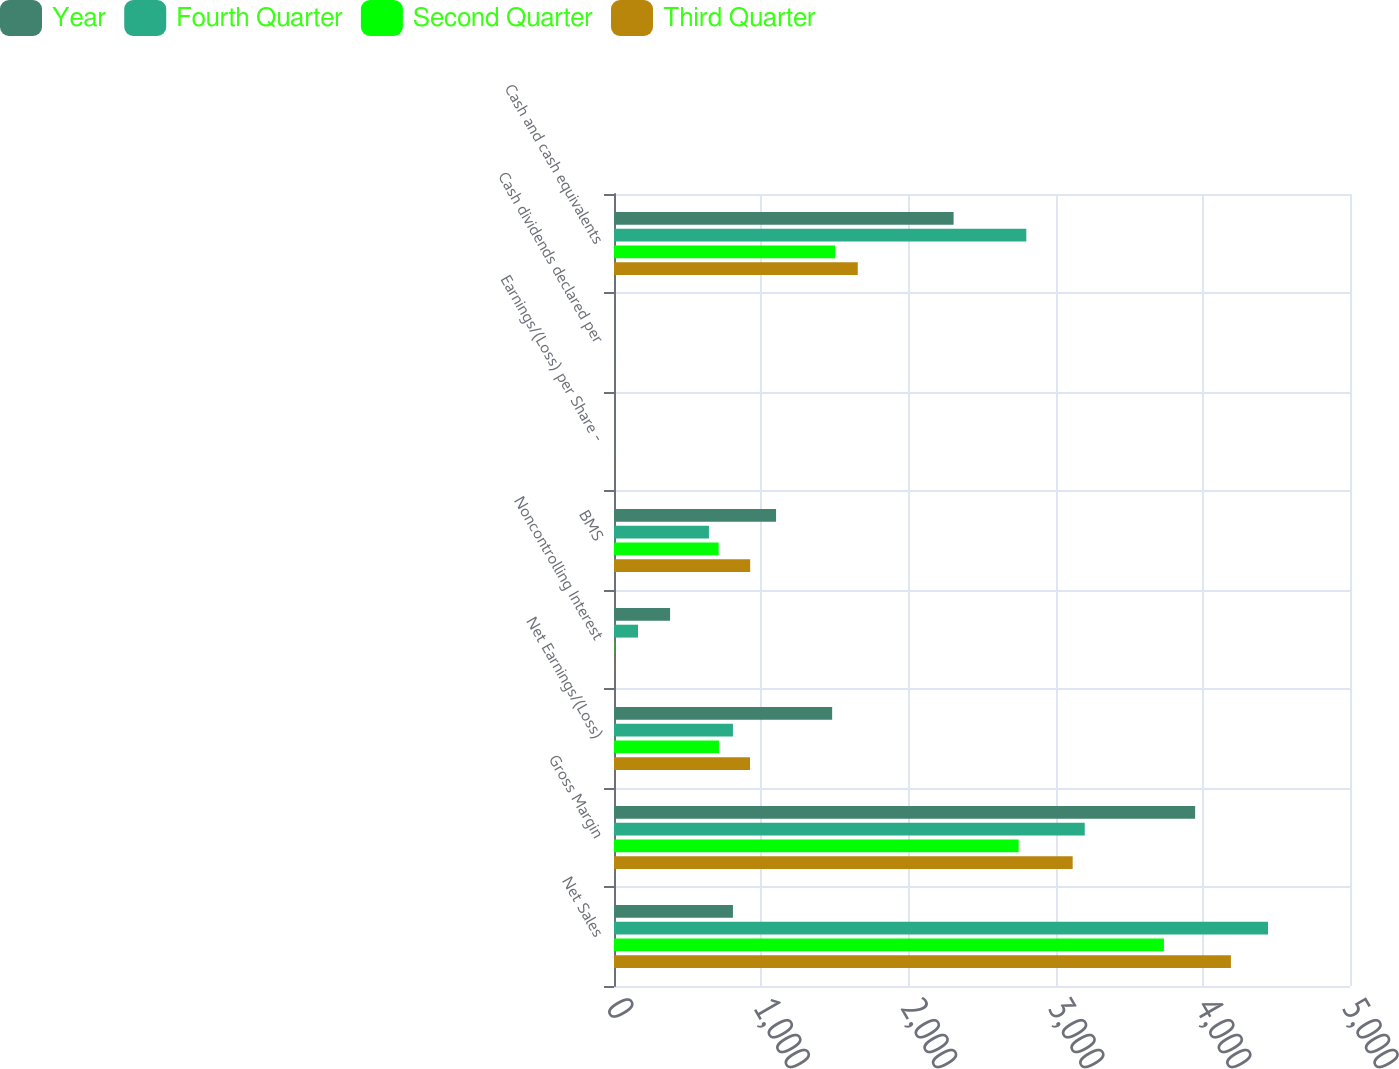<chart> <loc_0><loc_0><loc_500><loc_500><stacked_bar_chart><ecel><fcel>Net Sales<fcel>Gross Margin<fcel>Net Earnings/(Loss)<fcel>Noncontrolling Interest<fcel>BMS<fcel>Earnings/(Loss) per Share -<fcel>Cash dividends declared per<fcel>Cash and cash equivalents<nl><fcel>Year<fcel>808<fcel>3948<fcel>1482<fcel>381<fcel>1101<fcel>0.65<fcel>0.34<fcel>2307<nl><fcel>Fourth Quarter<fcel>4443<fcel>3198<fcel>808<fcel>163<fcel>645<fcel>0.38<fcel>0.34<fcel>2801<nl><fcel>Second Quarter<fcel>3736<fcel>2749<fcel>713<fcel>2<fcel>711<fcel>0.43<fcel>0.34<fcel>1503<nl><fcel>Third Quarter<fcel>4191<fcel>3116<fcel>924<fcel>1<fcel>925<fcel>0.56<fcel>0.35<fcel>1656<nl></chart> 